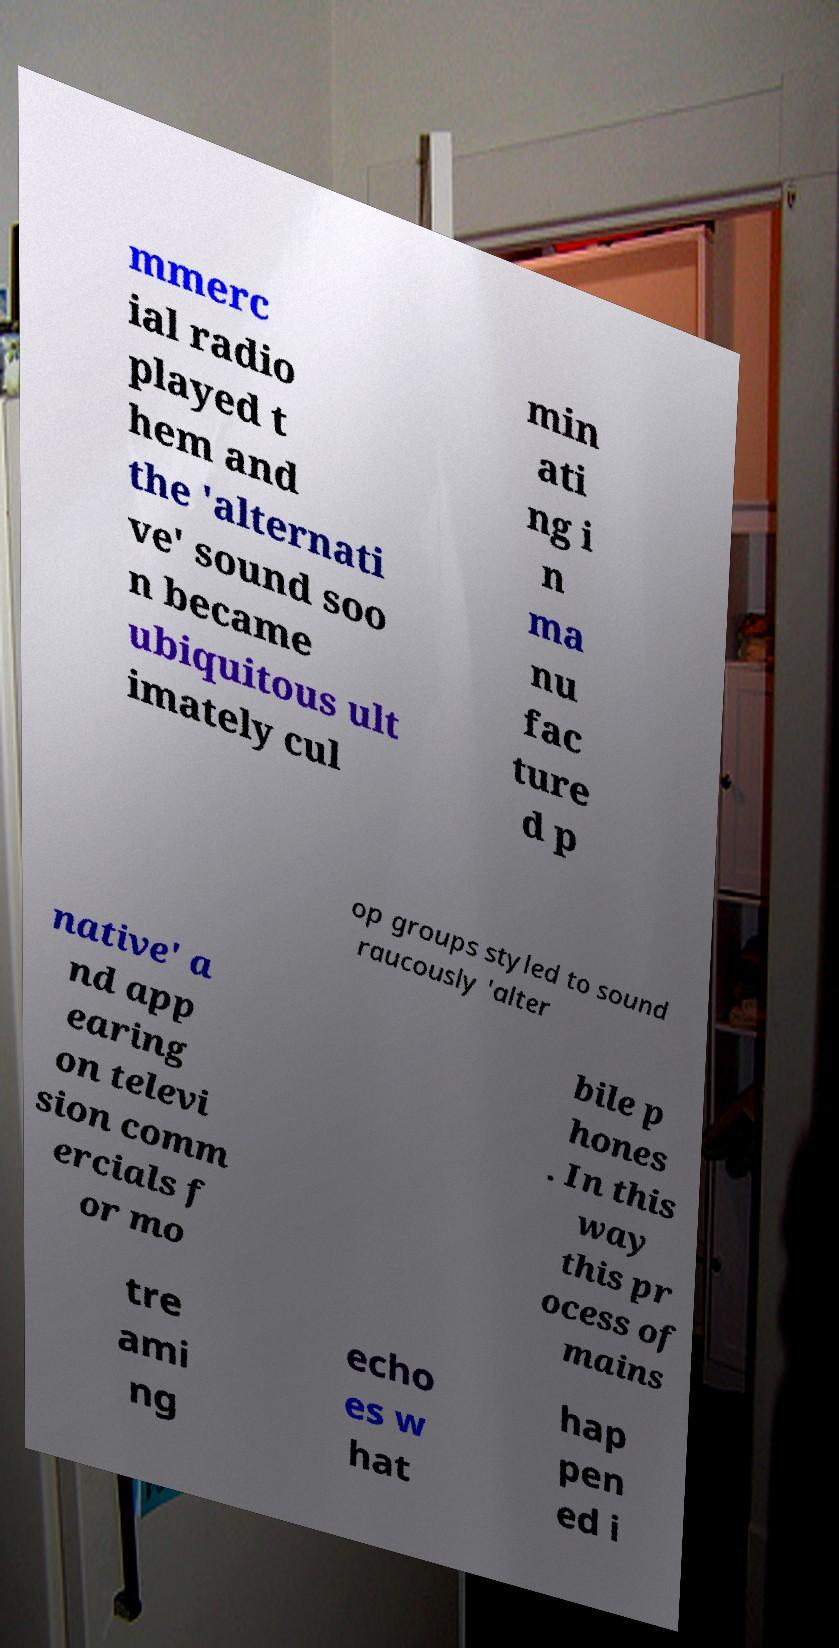Please identify and transcribe the text found in this image. mmerc ial radio played t hem and the 'alternati ve' sound soo n became ubiquitous ult imately cul min ati ng i n ma nu fac ture d p op groups styled to sound raucously 'alter native' a nd app earing on televi sion comm ercials f or mo bile p hones . In this way this pr ocess of mains tre ami ng echo es w hat hap pen ed i 